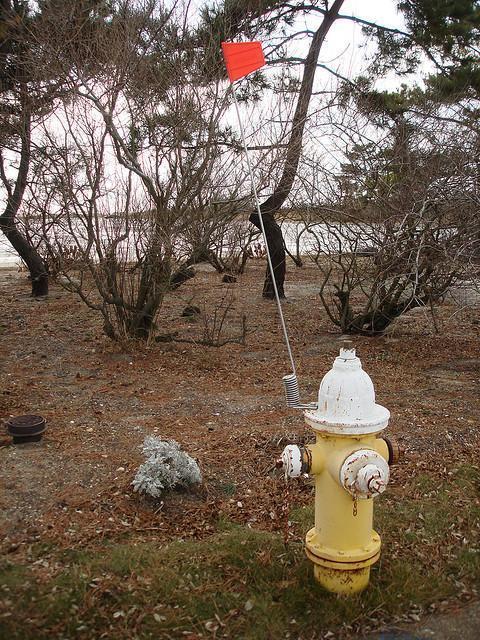How many fire hydrants are in the picture?
Give a very brief answer. 1. How many horses are pulling the front carriage?
Give a very brief answer. 0. 